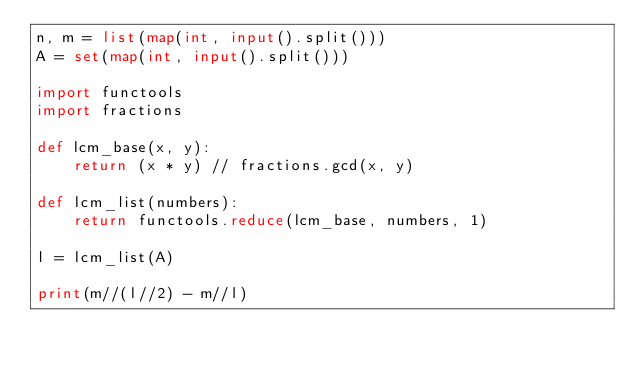<code> <loc_0><loc_0><loc_500><loc_500><_Python_>n, m = list(map(int, input().split()))
A = set(map(int, input().split()))

import functools
import fractions

def lcm_base(x, y):
    return (x * y) // fractions.gcd(x, y)

def lcm_list(numbers):
    return functools.reduce(lcm_base, numbers, 1)

l = lcm_list(A)

print(m//(l//2) - m//l)</code> 